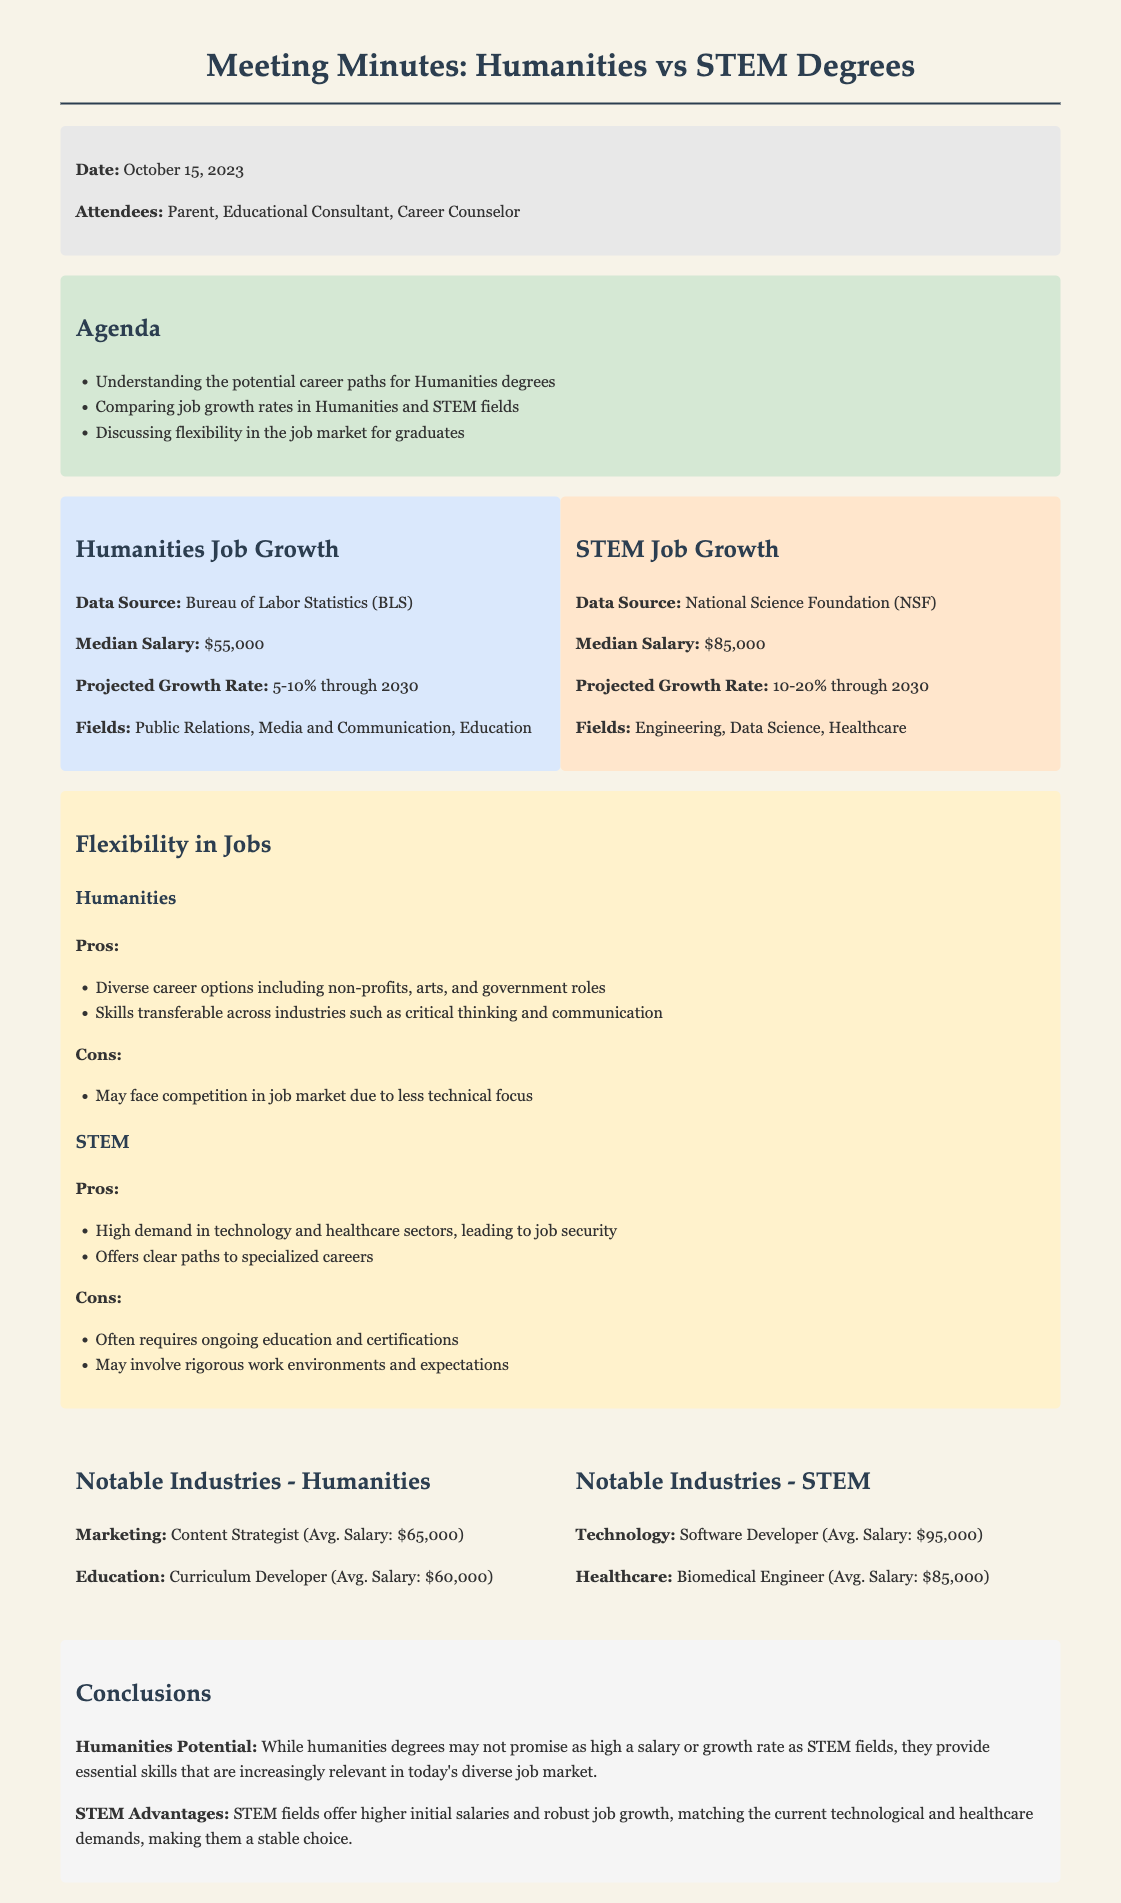What is the date of the meeting? The date of the meeting is explicitly mentioned at the beginning of the document.
Answer: October 15, 2023 What is the projected growth rate for Humanities jobs? The projected growth rate for Humanities jobs is provided in the comparative section of the document.
Answer: 5-10% What is the median salary for STEM degrees? The median salary for STEM degrees is stated directly under the STEM job growth section.
Answer: $85,000 What are the notable industries for Humanities graduates? The document lists notable industries for Humanities graduates in a specific section.
Answer: Marketing, Education What is one pro of pursuing a Humanities degree? The pros of pursuing a Humanities degree are listed under the flexibility section in the document.
Answer: Diverse career options What is one con of pursuing a STEM degree? The cons of pursuing a STEM degree are also provided under the flexibility section.
Answer: Often requires ongoing education What fields are mentioned for the growth of STEM jobs? The document clearly lists fields where STEM jobs are projected to grow.
Answer: Engineering, Data Science, Healthcare Which attendees were present at the meeting? The attendees are listed in the meeting information section at the beginning of the document.
Answer: Parent, Educational Consultant, Career Counselor 